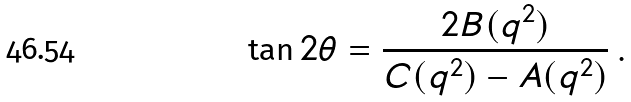<formula> <loc_0><loc_0><loc_500><loc_500>\tan 2 \theta = \frac { 2 B ( q ^ { 2 } ) } { C ( q ^ { 2 } ) - A ( q ^ { 2 } ) } \, .</formula> 